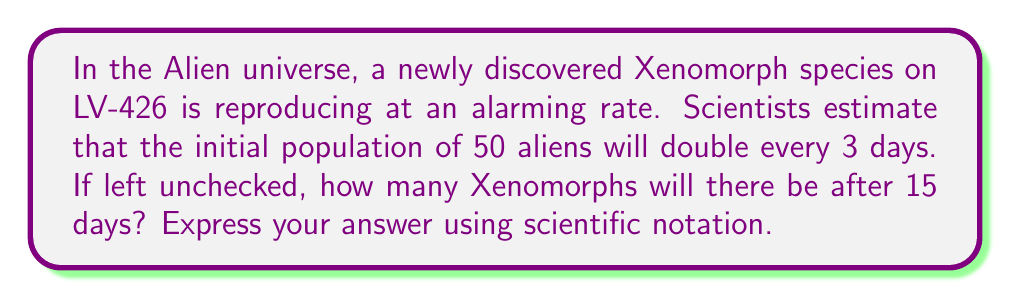What is the answer to this math problem? Let's approach this problem step-by-step using an exponential growth function:

1) The general form of an exponential growth function is:
   $$ A(t) = A_0 \cdot b^t $$
   Where:
   $A(t)$ is the amount after time $t$
   $A_0$ is the initial amount
   $b$ is the growth factor per unit time
   $t$ is the time elapsed

2) We know:
   - Initial population, $A_0 = 50$
   - The population doubles every 3 days
   - We want to know the population after 15 days

3) To find $b$, we use the doubling time:
   $$ 2 = b^3 $$
   $$ b = 2^{\frac{1}{3}} \approx 1.2599 $$

4) Now we can set up our function:
   $$ A(t) = 50 \cdot (1.2599)^{\frac{t}{3}} $$
   We divide $t$ by 3 because our growth factor is per 3 days.

5) Plugging in $t = 15$:
   $$ A(15) = 50 \cdot (1.2599)^5 $$

6) Calculate:
   $$ A(15) = 50 \cdot 3.17937 = 158.9685 $$

7) Rounding to the nearest whole number (as we can't have a fraction of a Xenomorph):
   $$ A(15) \approx 159 $$

8) In scientific notation:
   $$ A(15) \approx 1.59 \times 10^2 $$
Answer: $1.59 \times 10^2$ Xenomorphs 